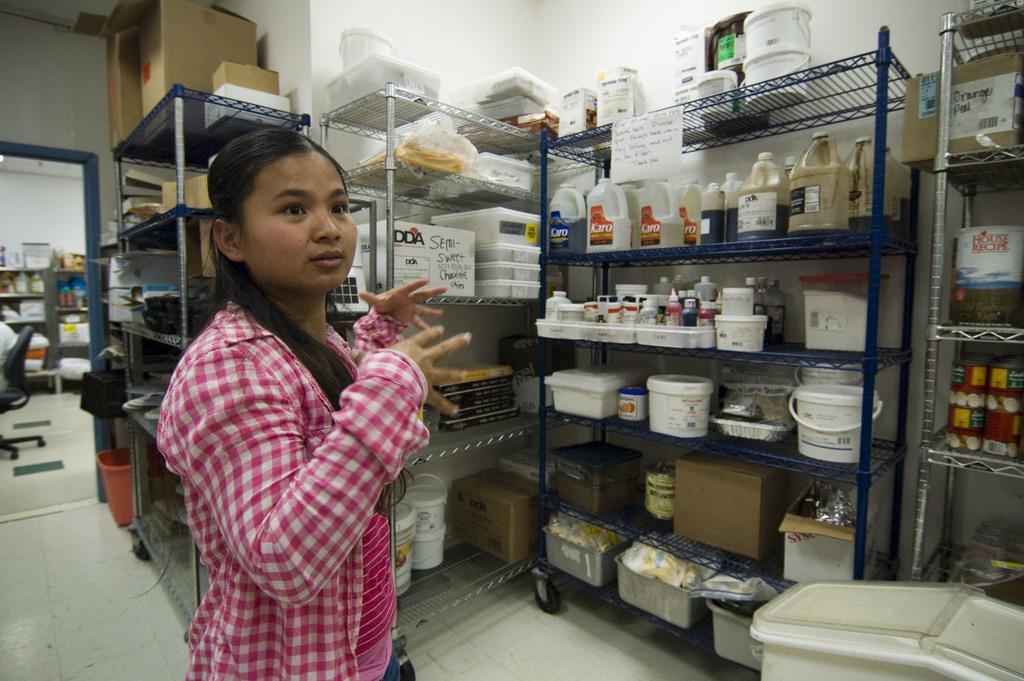Can you describe this image briefly? In this image, we can see a lady standing and in the background, there are bottles, containers, buckets which are placed in the racks. At the bottom, there is floor and on the left, we can see a chair. 